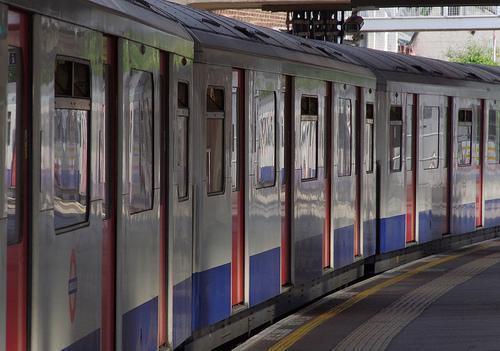How many trains are there?
Give a very brief answer. 1. 